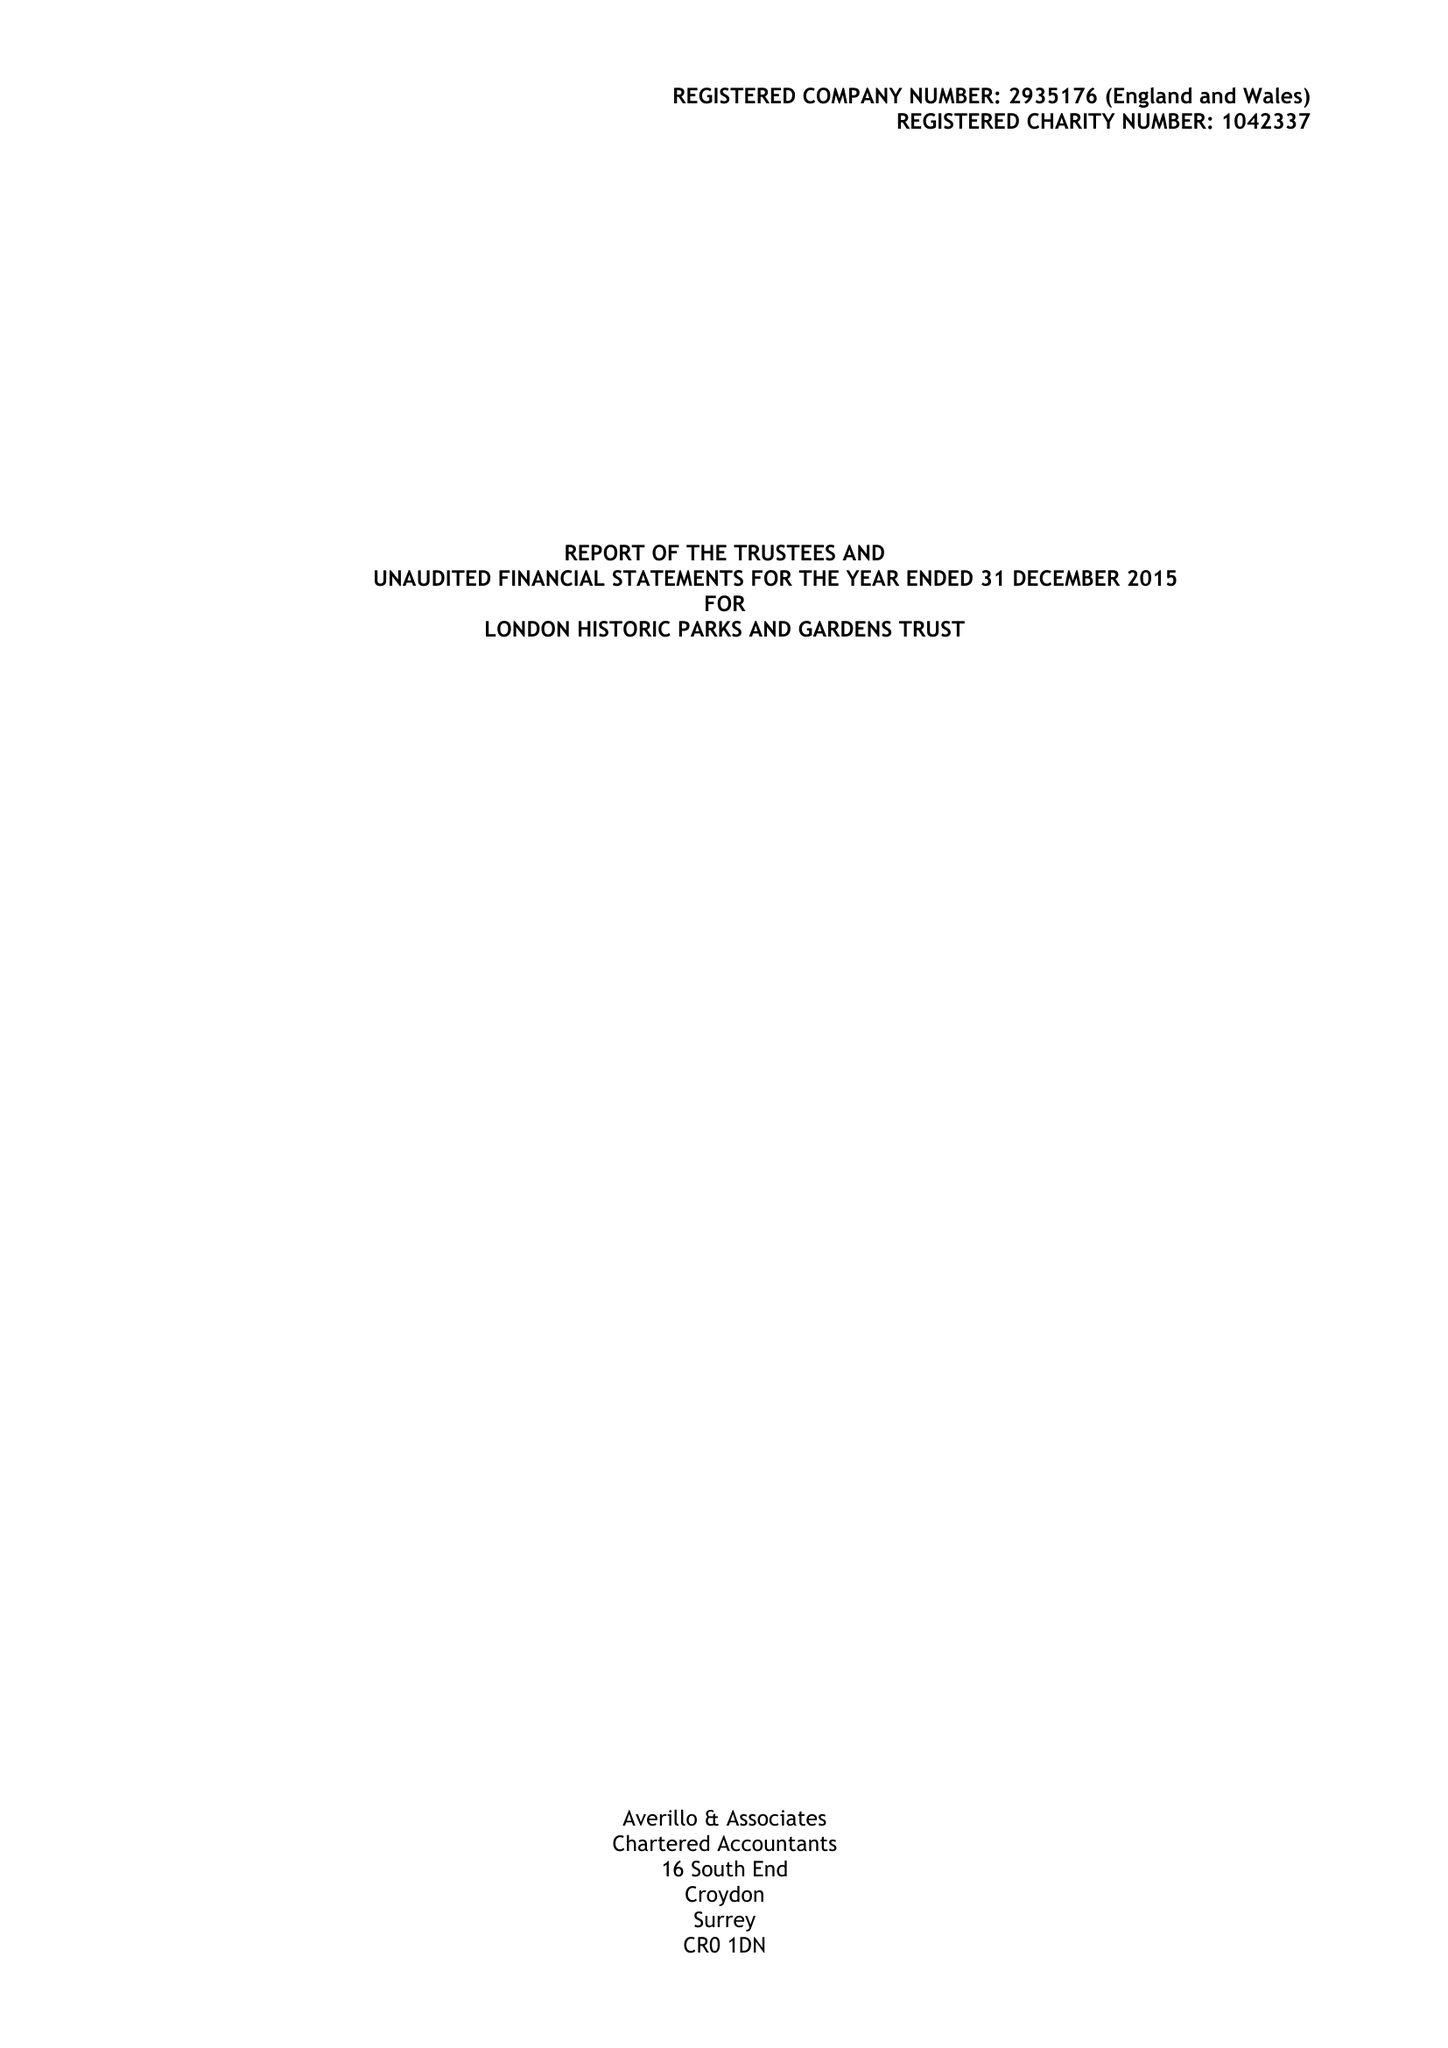What is the value for the address__street_line?
Answer the question using a single word or phrase. ST JAMES PARK 